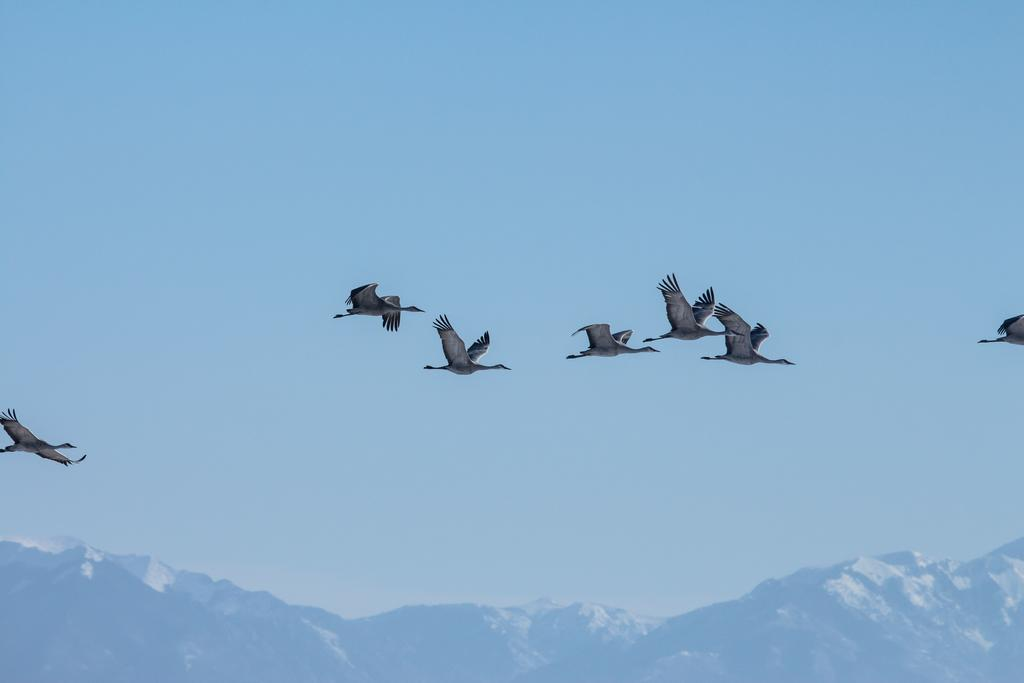What type of animals can be seen in the image? There are birds in the image. What are the birds doing in the image? The birds are flying in the air. What color are the birds in the image? The birds are gray in color. What can be seen in the background of the image? The sky is visible in the background of the image. What is the color of the sky in the image? The sky is blue in color. Where is the cushion placed in the image? A: There is no cushion present in the image. What type of clock can be seen in the image? There is no clock present in the image. 